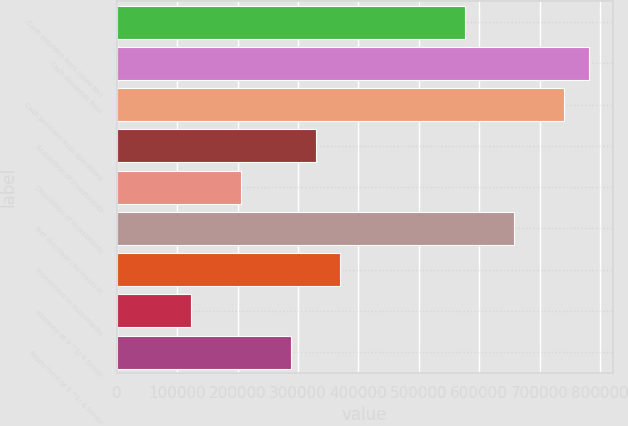<chart> <loc_0><loc_0><loc_500><loc_500><bar_chart><fcel>Cash provided from (used for)<fcel>Cash dividends from<fcel>Cash provided from operations<fcel>Acquisition of investments<fcel>Disposition of investments<fcel>Net decrease (increase) in<fcel>Investment in subsidiaries<fcel>Issuance of 9 ^1/ 4 Senior<fcel>Repayment of 9 ^1/ 4 Senior<nl><fcel>576040<fcel>781768<fcel>740623<fcel>329166<fcel>205729<fcel>658331<fcel>370311<fcel>123437<fcel>288020<nl></chart> 